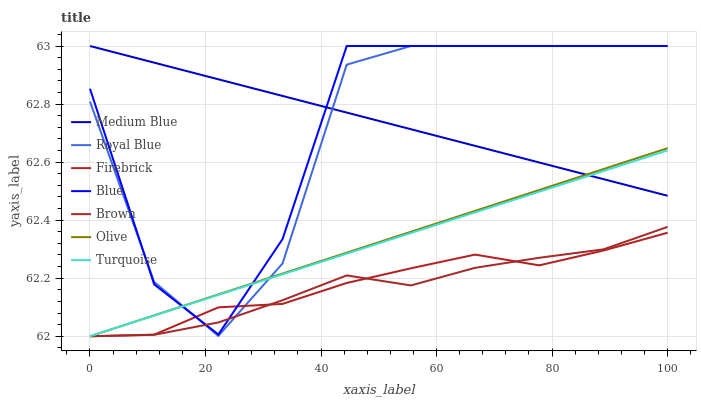Does Brown have the minimum area under the curve?
Answer yes or no. Yes. Does Medium Blue have the maximum area under the curve?
Answer yes or no. Yes. Does Turquoise have the minimum area under the curve?
Answer yes or no. No. Does Turquoise have the maximum area under the curve?
Answer yes or no. No. Is Olive the smoothest?
Answer yes or no. Yes. Is Blue the roughest?
Answer yes or no. Yes. Is Brown the smoothest?
Answer yes or no. No. Is Brown the roughest?
Answer yes or no. No. Does Brown have the lowest value?
Answer yes or no. Yes. Does Medium Blue have the lowest value?
Answer yes or no. No. Does Royal Blue have the highest value?
Answer yes or no. Yes. Does Brown have the highest value?
Answer yes or no. No. Is Firebrick less than Medium Blue?
Answer yes or no. Yes. Is Medium Blue greater than Brown?
Answer yes or no. Yes. Does Firebrick intersect Brown?
Answer yes or no. Yes. Is Firebrick less than Brown?
Answer yes or no. No. Is Firebrick greater than Brown?
Answer yes or no. No. Does Firebrick intersect Medium Blue?
Answer yes or no. No. 